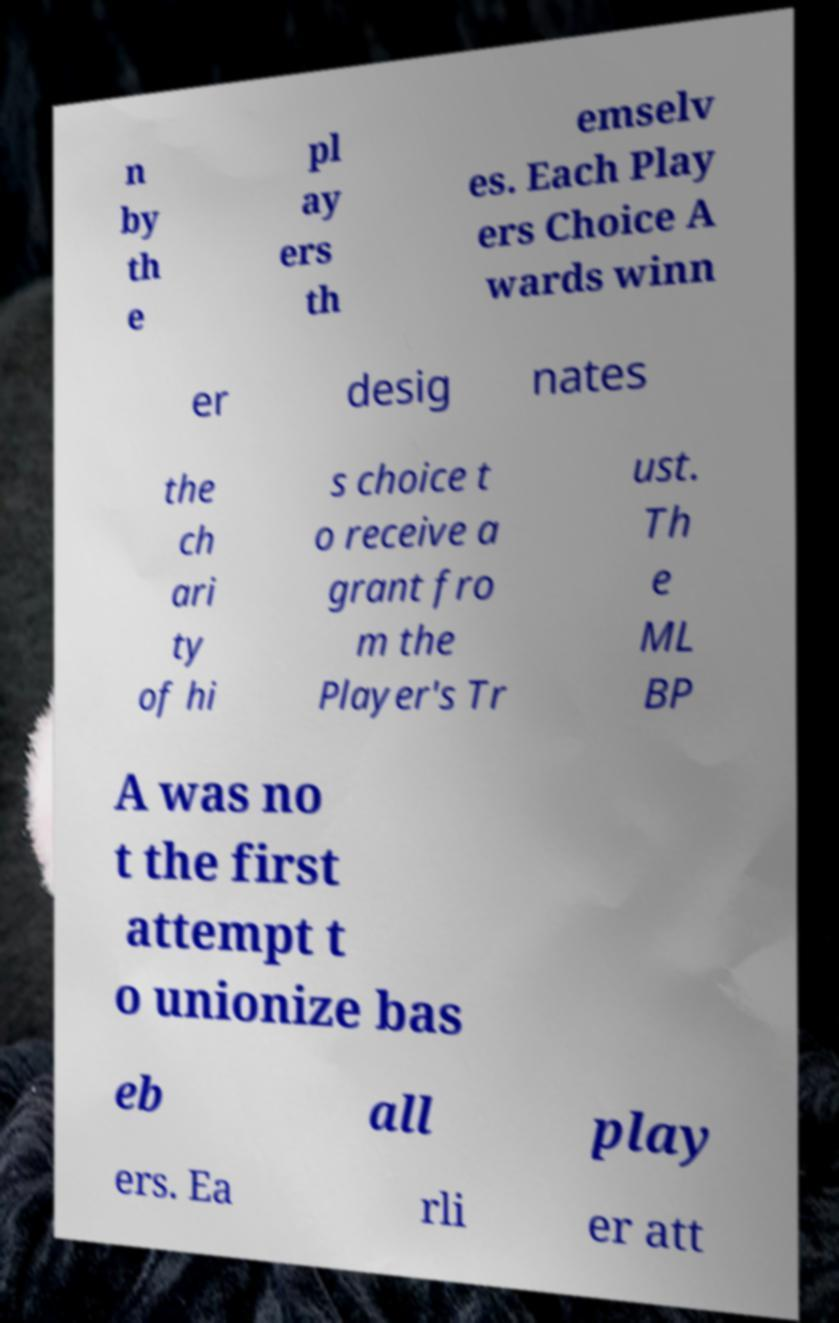I need the written content from this picture converted into text. Can you do that? n by th e pl ay ers th emselv es. Each Play ers Choice A wards winn er desig nates the ch ari ty of hi s choice t o receive a grant fro m the Player's Tr ust. Th e ML BP A was no t the first attempt t o unionize bas eb all play ers. Ea rli er att 